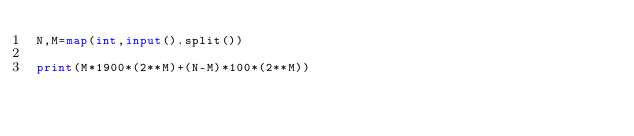<code> <loc_0><loc_0><loc_500><loc_500><_Python_>N,M=map(int,input().split())

print(M*1900*(2**M)+(N-M)*100*(2**M))
</code> 